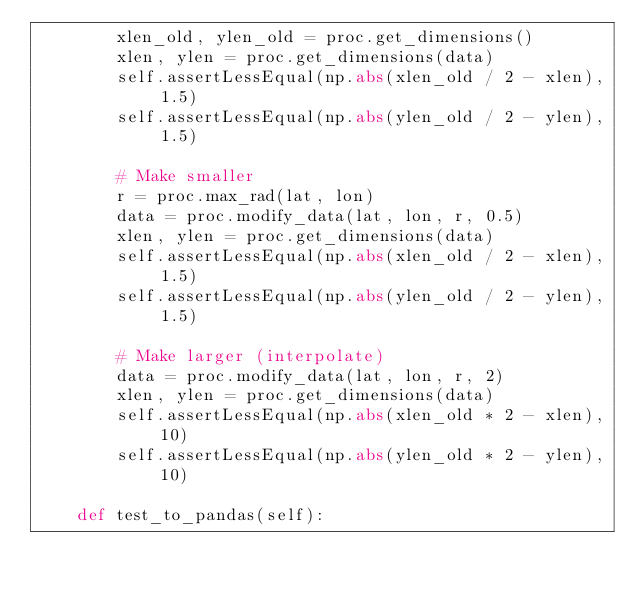Convert code to text. <code><loc_0><loc_0><loc_500><loc_500><_Python_>        xlen_old, ylen_old = proc.get_dimensions()
        xlen, ylen = proc.get_dimensions(data)
        self.assertLessEqual(np.abs(xlen_old / 2 - xlen), 1.5)
        self.assertLessEqual(np.abs(ylen_old / 2 - ylen), 1.5)

        # Make smaller
        r = proc.max_rad(lat, lon)
        data = proc.modify_data(lat, lon, r, 0.5)
        xlen, ylen = proc.get_dimensions(data)
        self.assertLessEqual(np.abs(xlen_old / 2 - xlen), 1.5)
        self.assertLessEqual(np.abs(ylen_old / 2 - ylen), 1.5)

        # Make larger (interpolate)
        data = proc.modify_data(lat, lon, r, 2)
        xlen, ylen = proc.get_dimensions(data)
        self.assertLessEqual(np.abs(xlen_old * 2 - xlen), 10)
        self.assertLessEqual(np.abs(ylen_old * 2 - ylen), 10)

    def test_to_pandas(self):</code> 